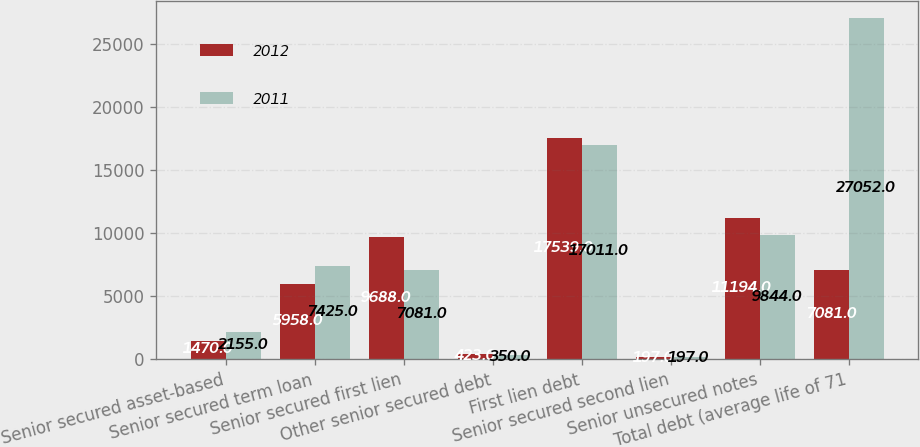<chart> <loc_0><loc_0><loc_500><loc_500><stacked_bar_chart><ecel><fcel>Senior secured asset-based<fcel>Senior secured term loan<fcel>Senior secured first lien<fcel>Other senior secured debt<fcel>First lien debt<fcel>Senior secured second lien<fcel>Senior unsecured notes<fcel>Total debt (average life of 71<nl><fcel>2012<fcel>1470<fcel>5958<fcel>9688<fcel>423<fcel>17539<fcel>197<fcel>11194<fcel>7081<nl><fcel>2011<fcel>2155<fcel>7425<fcel>7081<fcel>350<fcel>17011<fcel>197<fcel>9844<fcel>27052<nl></chart> 